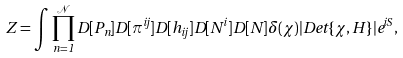<formula> <loc_0><loc_0><loc_500><loc_500>Z = \int \prod _ { n = 1 } ^ { \mathcal { N } } D [ P _ { n } ] D [ \pi ^ { i j } ] D [ h _ { i j } ] D [ N ^ { i } ] D [ N ] \delta ( \chi ) | D e t \{ \chi , H \} | e ^ { i S } ,</formula> 